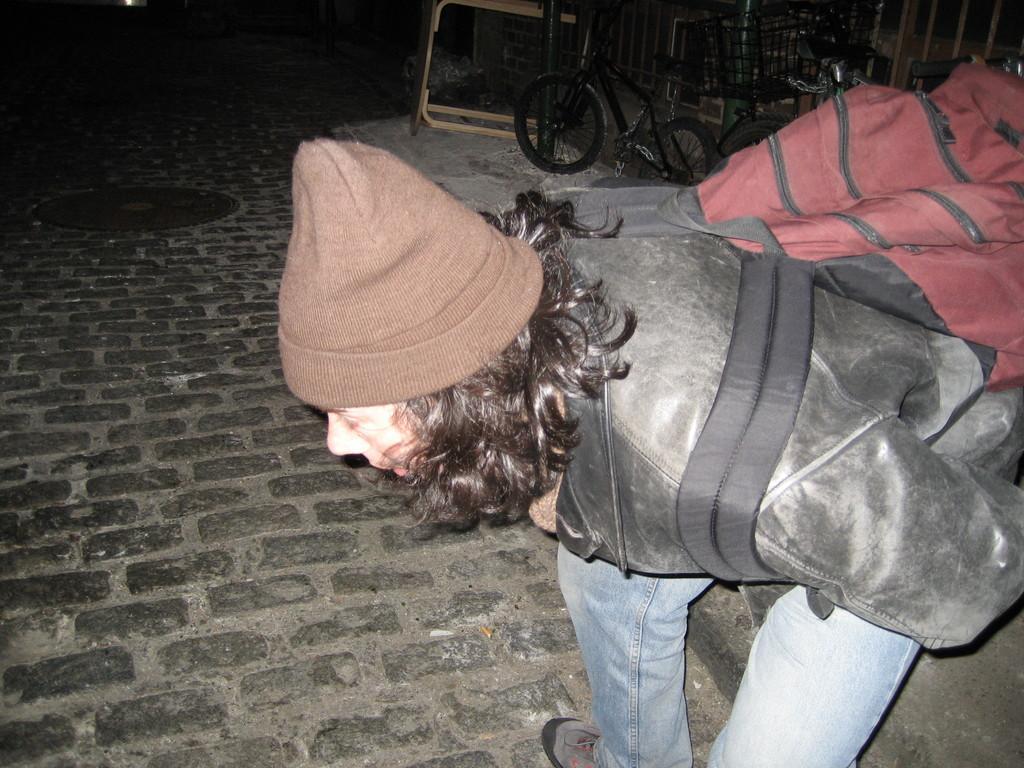Can you describe this image briefly? In this picture we can see a person wore cap,jacket,shoe and a bag pack. He is bending and facing towards the brick floor. In the background we can see manhole, bicycle tied with a chain to the wall and a pole and wood. 